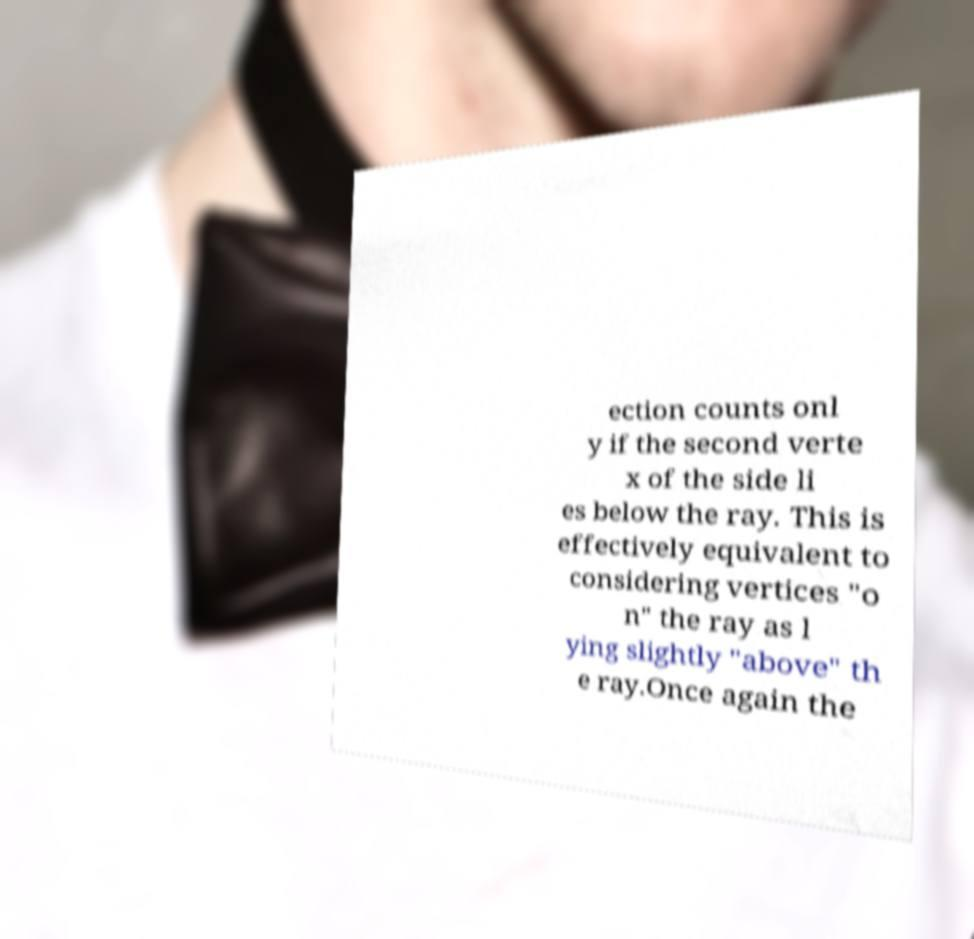Can you accurately transcribe the text from the provided image for me? ection counts onl y if the second verte x of the side li es below the ray. This is effectively equivalent to considering vertices "o n" the ray as l ying slightly "above" th e ray.Once again the 